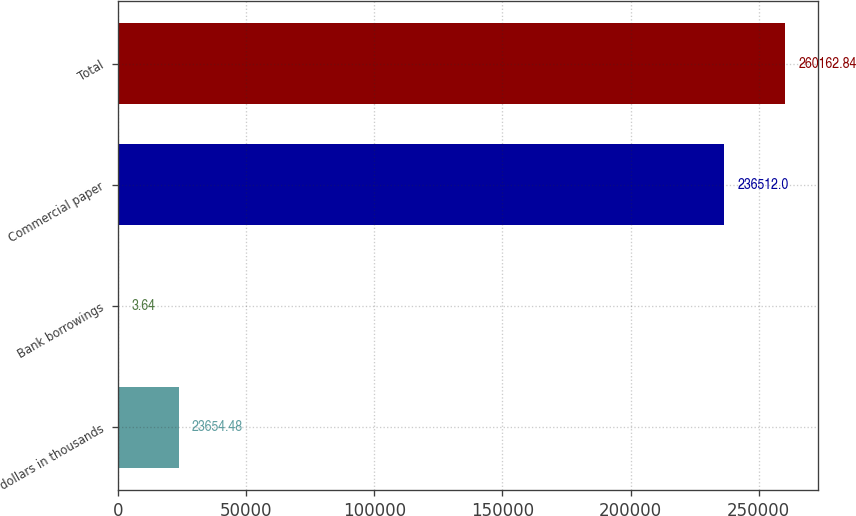<chart> <loc_0><loc_0><loc_500><loc_500><bar_chart><fcel>dollars in thousands<fcel>Bank borrowings<fcel>Commercial paper<fcel>Total<nl><fcel>23654.5<fcel>3.64<fcel>236512<fcel>260163<nl></chart> 